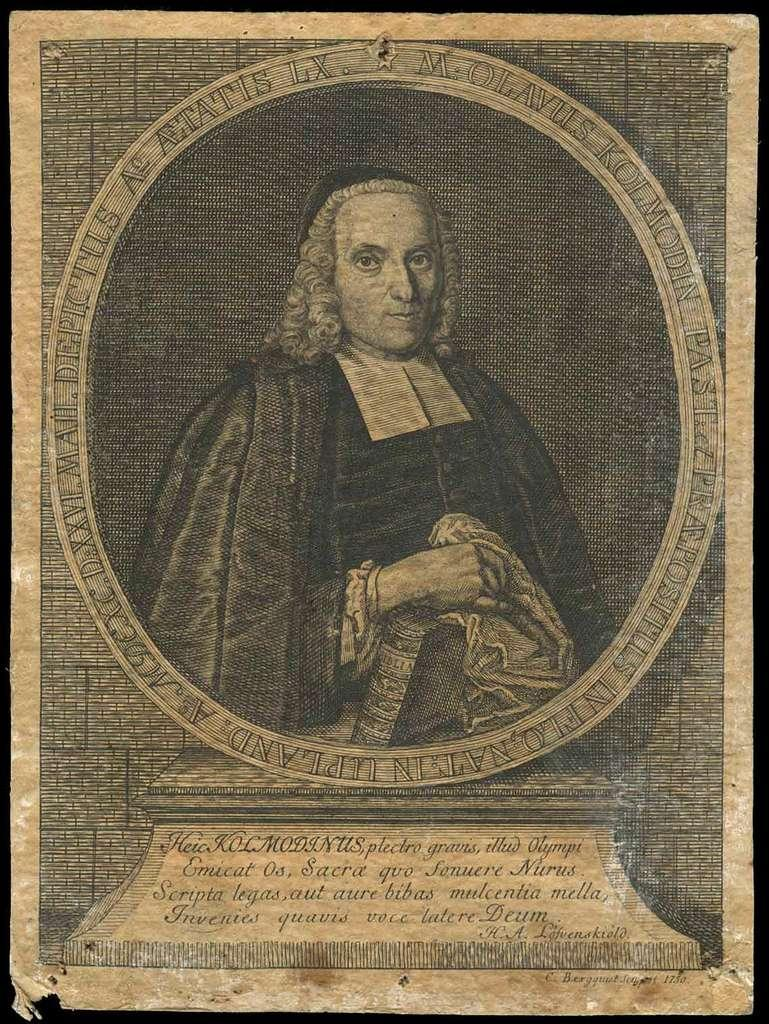<image>
Share a concise interpretation of the image provided. A quote by H.A.Lofvenskiod sits beneath an old photograph of a man 